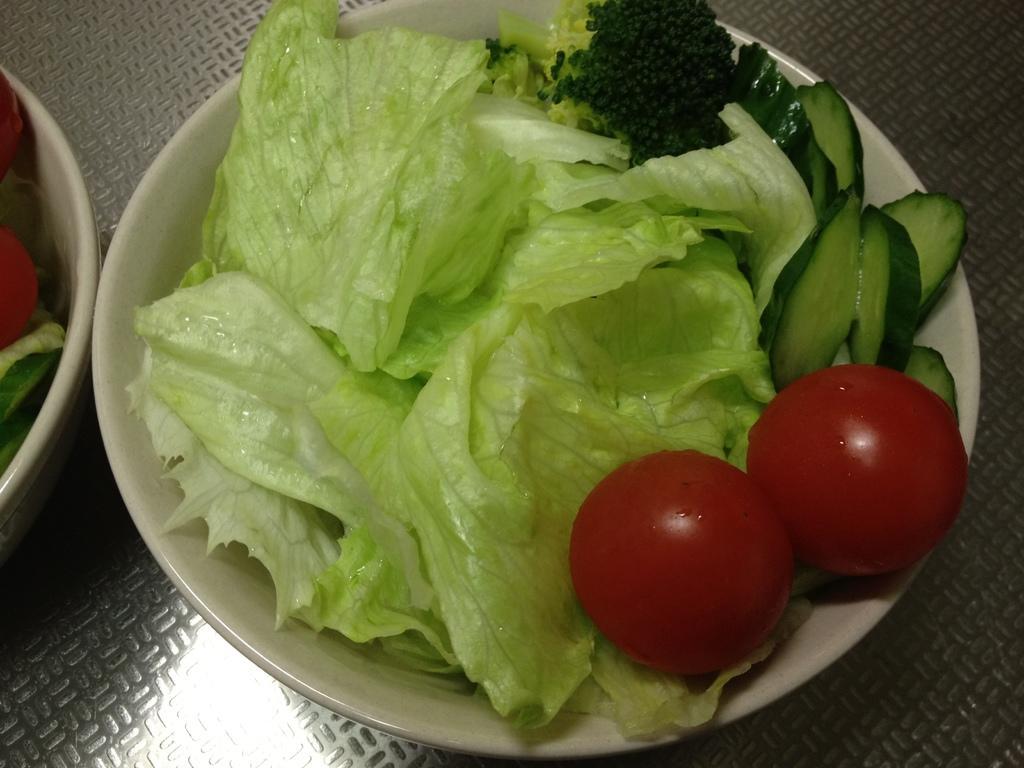How would you summarize this image in a sentence or two? In a bowl we can see cabbage leaves, two red tomatoes, cucumber pieces and other black seeds. On the left we can see vegetables in a white bowl. In the back we can see table. 